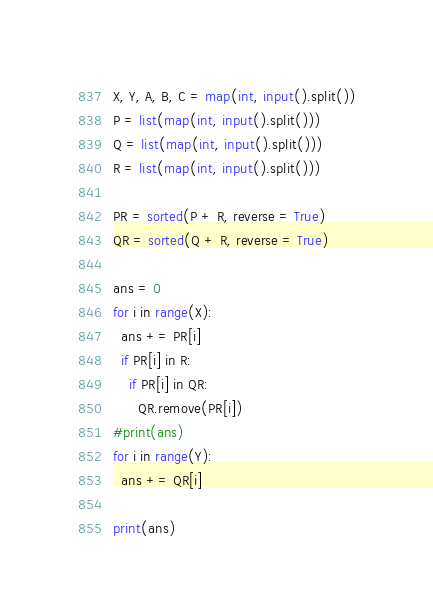<code> <loc_0><loc_0><loc_500><loc_500><_Python_>X, Y, A, B, C = map(int, input().split())
P = list(map(int, input().split()))
Q = list(map(int, input().split()))
R = list(map(int, input().split()))

PR = sorted(P + R, reverse = True)
QR = sorted(Q + R, reverse = True)

ans = 0
for i in range(X):
  ans += PR[i]
  if PR[i] in R:
    if PR[i] in QR:
      QR.remove(PR[i])
#print(ans)
for i in range(Y):
  ans += QR[i]
  
print(ans)
</code> 